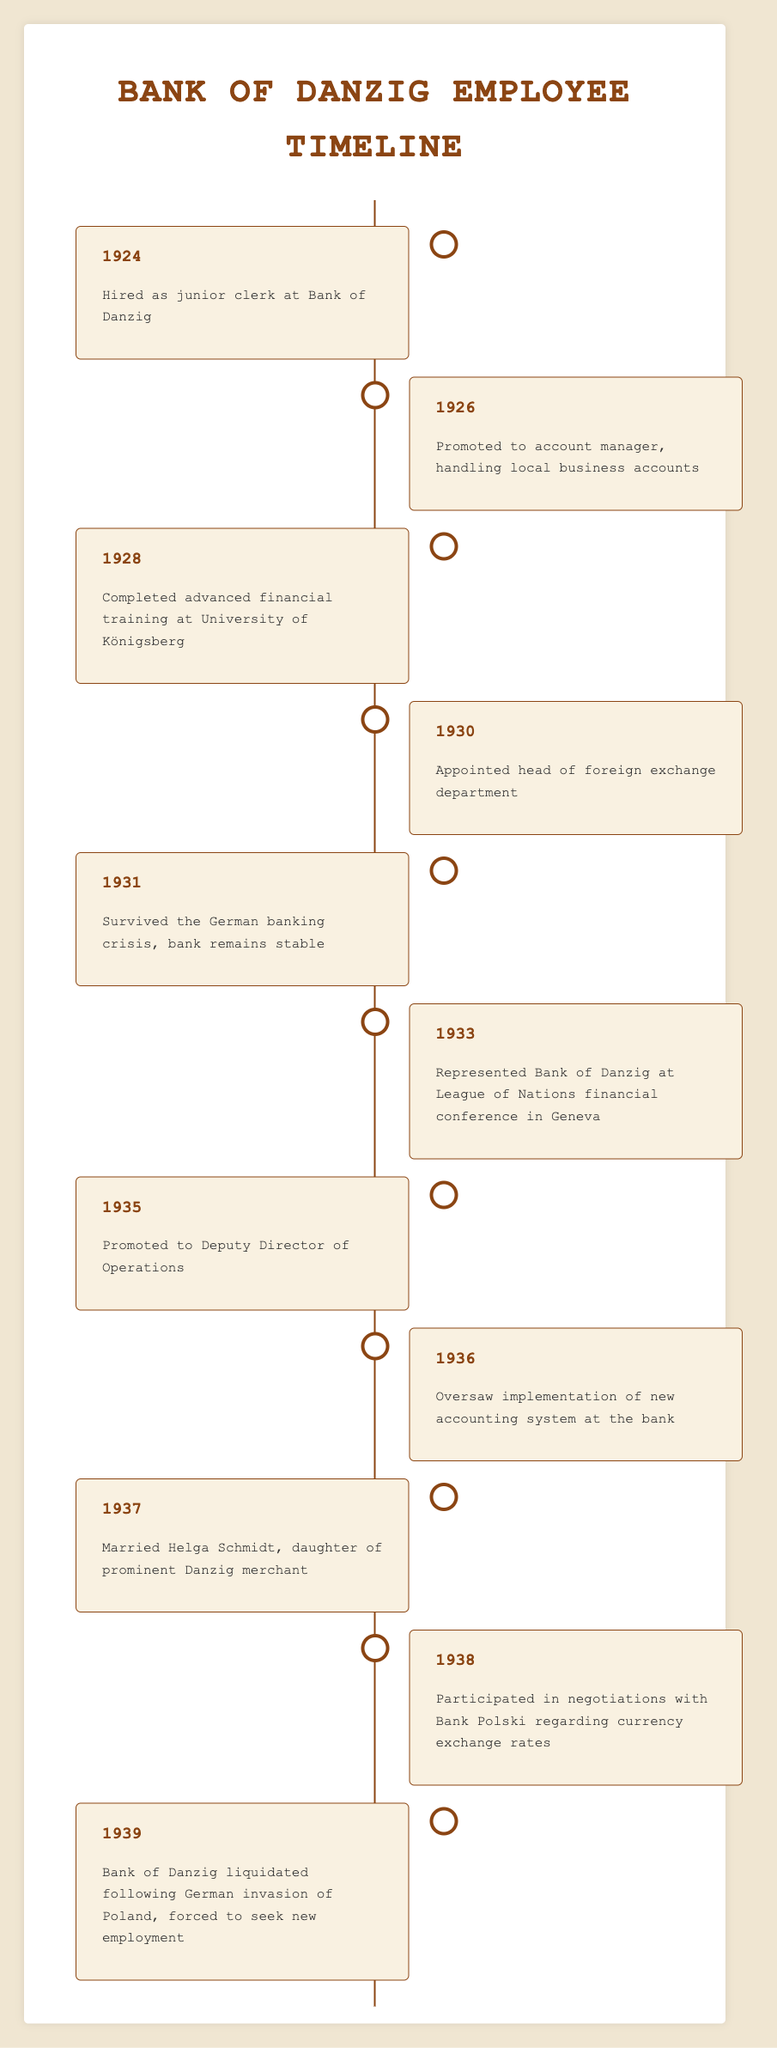What year was the Bank of Danzig employee hired? The timeline shows that the employee was hired as a junior clerk in 1924, as indicated in the first entry.
Answer: 1924 In what year did the employee complete advanced financial training at the University of Königsberg? The timeline indicates that the advanced financial training was completed in 1928, which is detailed in the third entry.
Answer: 1928 Was the employee involved in any significant international conferences? Yes, the timeline mentions that the employee represented the Bank of Danzig at the League of Nations financial conference in Geneva in 1933.
Answer: Yes How many years did the employee serve in the bank before it was liquidated? The employee started in 1924 and the bank was liquidated in 1939, so the duration of service is 1939 - 1924 = 15 years.
Answer: 15 years What was one major event that occurred in 1931? The timeline documents that in 1931, the employee survived the German banking crisis, which is a significant event for the bank's stability.
Answer: Survived the German banking crisis How many promotions did the employee receive throughout their career at the bank? The timeline lists three promotions: to account manager in 1926, to head of foreign exchange department in 1930, and to Deputy Director of Operations in 1935, totaling three promotions.
Answer: Three promotions In what year did the employee marry, and what was the name of their spouse? The marriage occurred in 1937 to Helga Schmidt, as listed in the ninth entry of the timeline.
Answer: 1937; Helga Schmidt What significant change in the banking operation did the employee oversee in 1936? The timeline indicates that in 1936, the employee oversaw the implementation of a new accounting system at the bank, which is a significant operational change.
Answer: Implementation of new accounting system How many years passed between the employee's promotion to Deputy Director of Operations and the liquidation of the bank? The employee was promoted in 1935 and the bank was liquidated in 1939, resulting in a duration of 1939 - 1935 = 4 years.
Answer: 4 years 